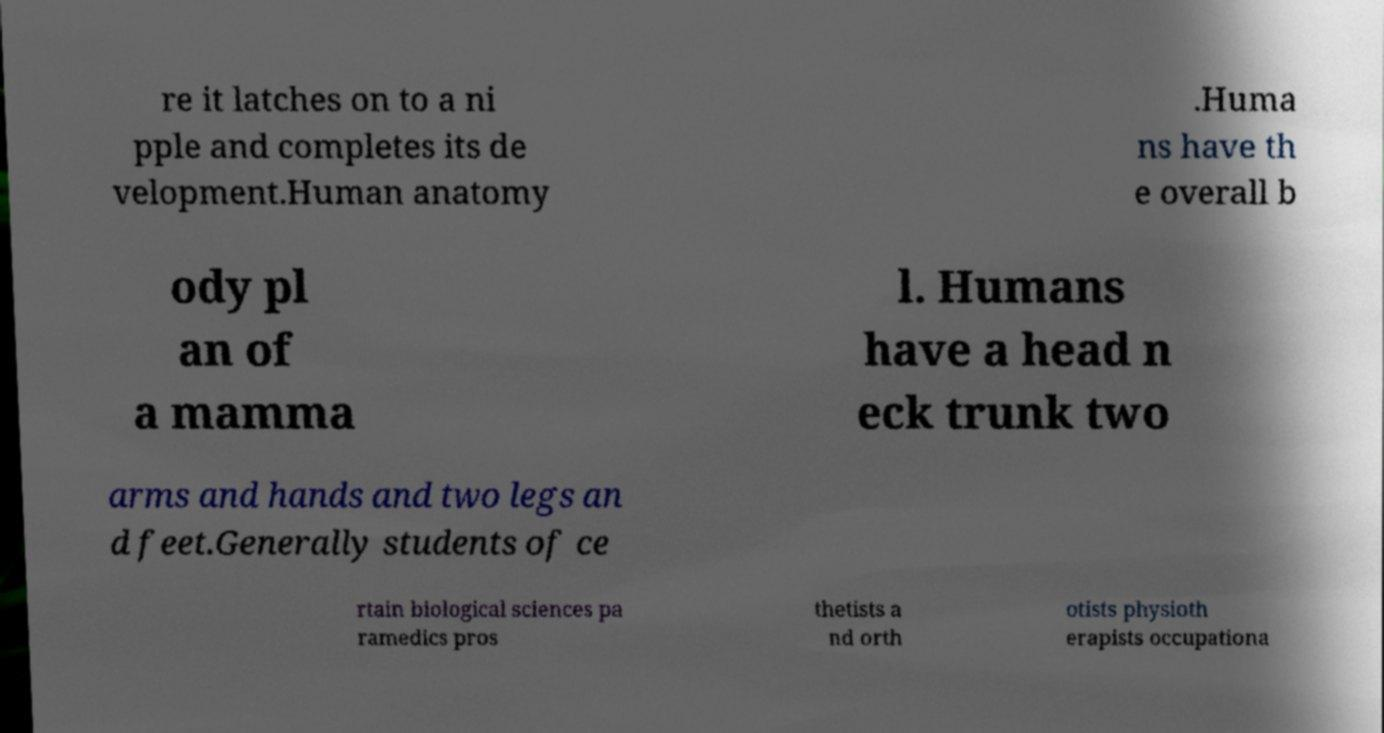I need the written content from this picture converted into text. Can you do that? re it latches on to a ni pple and completes its de velopment.Human anatomy .Huma ns have th e overall b ody pl an of a mamma l. Humans have a head n eck trunk two arms and hands and two legs an d feet.Generally students of ce rtain biological sciences pa ramedics pros thetists a nd orth otists physioth erapists occupationa 